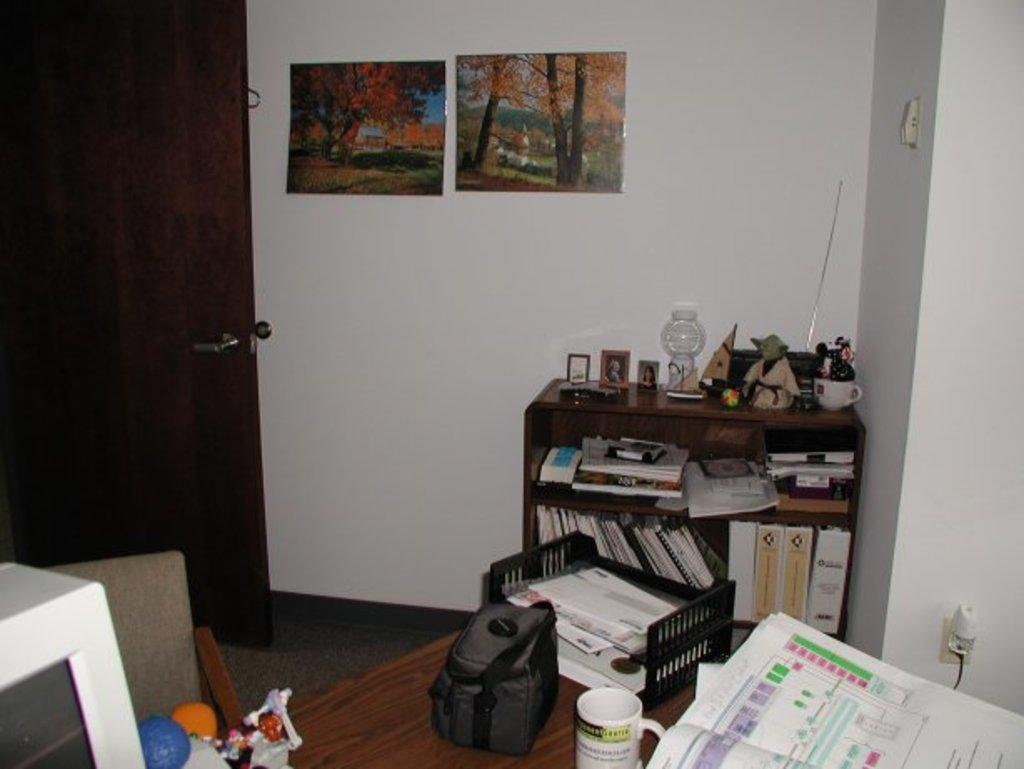What type of furniture is in the image? There is a table in the image. What is placed on the table? A backpack, a coffee mug, a monitor, books, and other decorative items are on the table. Can you describe the backpack on the table? The backpack is present on the table. What is the purpose of the monitor on the table? The monitor is likely used for displaying information or as a computer screen. Where is the sister sitting in the image? There is no sister present in the image. What type of crate is visible in the image? There is no crate present in the image. 